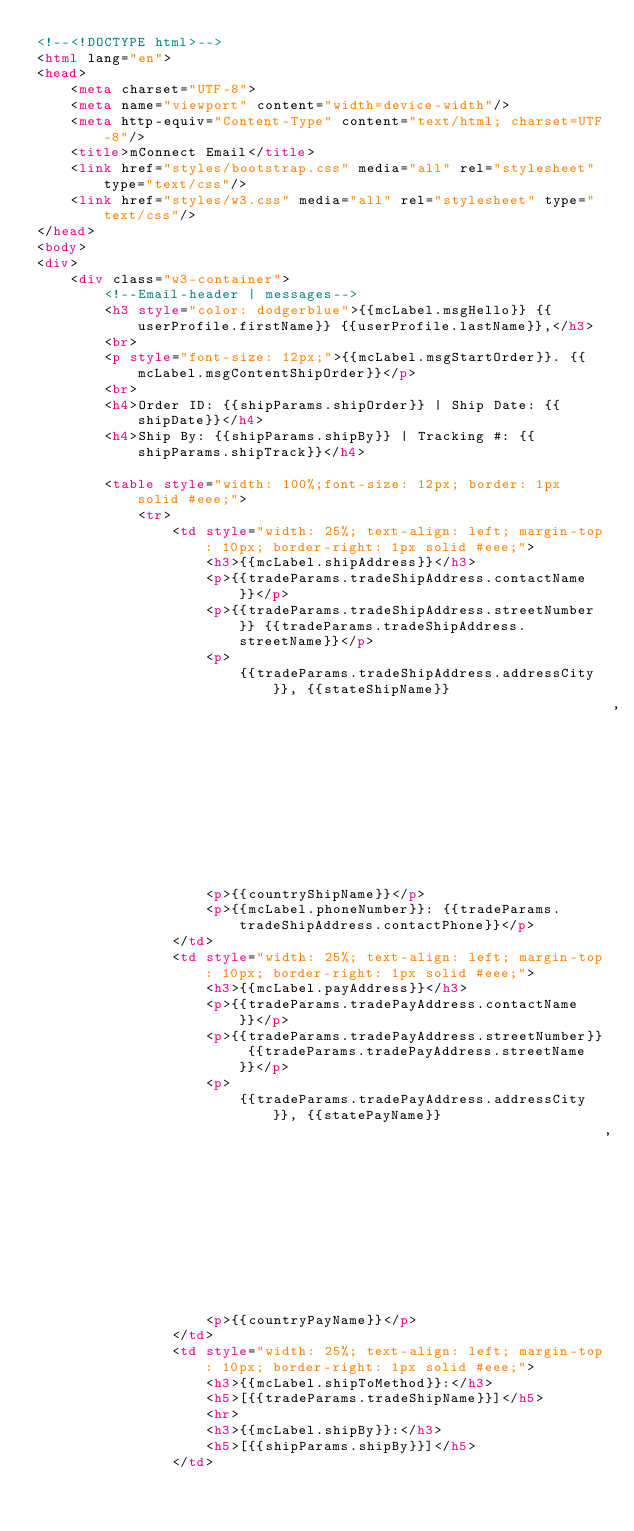Convert code to text. <code><loc_0><loc_0><loc_500><loc_500><_HTML_><!--<!DOCTYPE html>-->
<html lang="en">
<head>
    <meta charset="UTF-8">
    <meta name="viewport" content="width=device-width"/>
    <meta http-equiv="Content-Type" content="text/html; charset=UTF-8"/>
    <title>mConnect Email</title>
    <link href="styles/bootstrap.css" media="all" rel="stylesheet" type="text/css"/>
    <link href="styles/w3.css" media="all" rel="stylesheet" type="text/css"/>
</head>
<body>
<div>
    <div class="w3-container">
        <!--Email-header | messages-->
        <h3 style="color: dodgerblue">{{mcLabel.msgHello}} {{userProfile.firstName}} {{userProfile.lastName}},</h3>
        <br>
        <p style="font-size: 12px;">{{mcLabel.msgStartOrder}}. {{mcLabel.msgContentShipOrder}}</p>
        <br>
        <h4>Order ID: {{shipParams.shipOrder}} | Ship Date: {{shipDate}}</h4>
        <h4>Ship By: {{shipParams.shipBy}} | Tracking #: {{shipParams.shipTrack}}</h4>

        <table style="width: 100%;font-size: 12px; border: 1px solid #eee;">
            <tr>
                <td style="width: 25%; text-align: left; margin-top: 10px; border-right: 1px solid #eee;">
                    <h3>{{mcLabel.shipAddress}}</h3>
                    <p>{{tradeParams.tradeShipAddress.contactName}}</p>
                    <p>{{tradeParams.tradeShipAddress.streetNumber}} {{tradeParams.tradeShipAddress.streetName}}</p>
                    <p>
                        {{tradeParams.tradeShipAddress.addressCity}}, {{stateShipName}}
                                                                    , {{tradeParams.tradeShipAddress.postalCode}}</p>
                    <p>{{countryShipName}}</p>
                    <p>{{mcLabel.phoneNumber}}: {{tradeParams.tradeShipAddress.contactPhone}}</p>
                </td>
                <td style="width: 25%; text-align: left; margin-top: 10px; border-right: 1px solid #eee;">
                    <h3>{{mcLabel.payAddress}}</h3>
                    <p>{{tradeParams.tradePayAddress.contactName}}</p>
                    <p>{{tradeParams.tradePayAddress.streetNumber}} {{tradeParams.tradePayAddress.streetName}}</p>
                    <p>
                        {{tradeParams.tradePayAddress.addressCity}}, {{statePayName}}
                                                                   , {{tradeParams.tradePayAddress.postalCode}}</p>
                    <p>{{countryPayName}}</p>
                </td>
                <td style="width: 25%; text-align: left; margin-top: 10px; border-right: 1px solid #eee;">
                    <h3>{{mcLabel.shipToMethod}}:</h3>
                    <h5>[{{tradeParams.tradeShipName}}]</h5>
                    <hr>
                    <h3>{{mcLabel.shipBy}}:</h3>
                    <h5>[{{shipParams.shipBy}}]</h5>
                </td></code> 